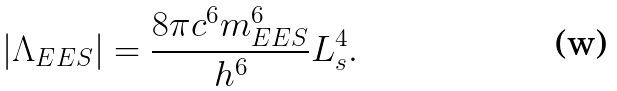<formula> <loc_0><loc_0><loc_500><loc_500>| \Lambda _ { E E S } | = \frac { 8 \pi c ^ { 6 } m _ { E E S } ^ { 6 } } { h ^ { 6 } } L _ { s } ^ { 4 } .</formula> 